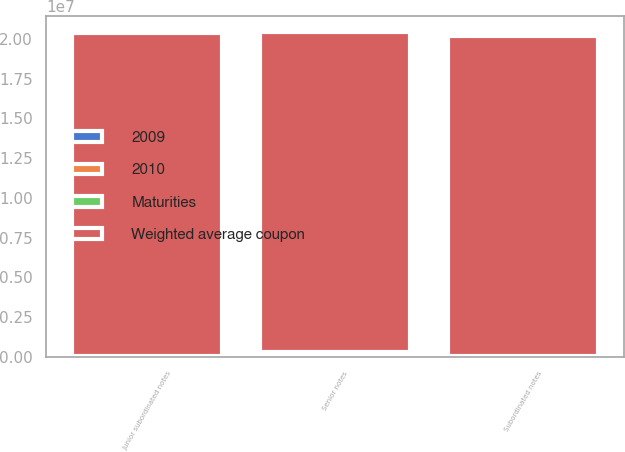<chart> <loc_0><loc_0><loc_500><loc_500><stacked_bar_chart><ecel><fcel>Senior notes<fcel>Subordinated notes<fcel>Junior subordinated notes<nl><fcel>2010<fcel>4.3<fcel>4.92<fcel>7.44<nl><fcel>Weighted average coupon<fcel>2.01121e+07<fcel>2.0112e+07<fcel>2.03121e+07<nl><fcel>Maturities<fcel>146280<fcel>27533<fcel>18131<nl><fcel>2009<fcel>149751<fcel>28708<fcel>19345<nl></chart> 